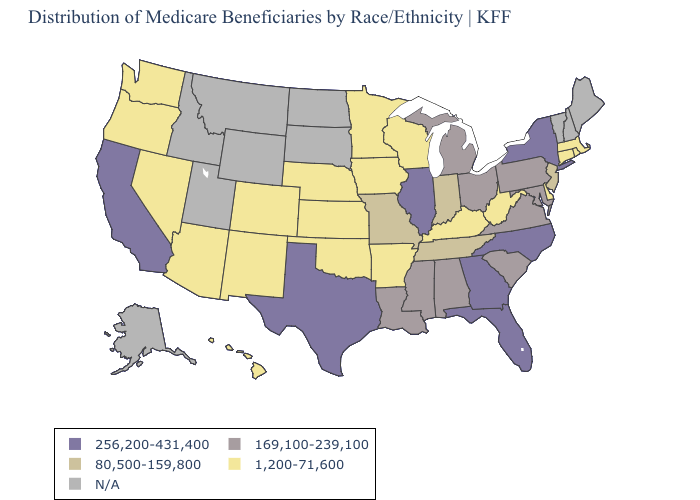What is the lowest value in the Northeast?
Be succinct. 1,200-71,600. What is the highest value in the USA?
Keep it brief. 256,200-431,400. Name the states that have a value in the range 80,500-159,800?
Write a very short answer. Indiana, Missouri, New Jersey, Tennessee. Among the states that border Delaware , which have the highest value?
Quick response, please. Maryland, Pennsylvania. Does Georgia have the highest value in the USA?
Give a very brief answer. Yes. Which states have the highest value in the USA?
Be succinct. California, Florida, Georgia, Illinois, New York, North Carolina, Texas. Among the states that border Iowa , which have the lowest value?
Be succinct. Minnesota, Nebraska, Wisconsin. Is the legend a continuous bar?
Give a very brief answer. No. How many symbols are there in the legend?
Short answer required. 5. What is the lowest value in the MidWest?
Quick response, please. 1,200-71,600. Name the states that have a value in the range 1,200-71,600?
Answer briefly. Arizona, Arkansas, Colorado, Connecticut, Delaware, Hawaii, Iowa, Kansas, Kentucky, Massachusetts, Minnesota, Nebraska, Nevada, New Mexico, Oklahoma, Oregon, Rhode Island, Washington, West Virginia, Wisconsin. Does the map have missing data?
Concise answer only. Yes. Name the states that have a value in the range 80,500-159,800?
Be succinct. Indiana, Missouri, New Jersey, Tennessee. Name the states that have a value in the range 80,500-159,800?
Be succinct. Indiana, Missouri, New Jersey, Tennessee. 